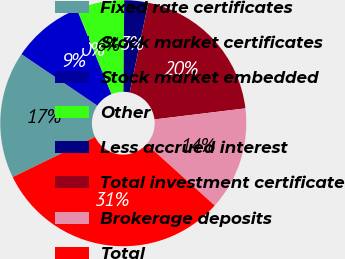Convert chart to OTSL. <chart><loc_0><loc_0><loc_500><loc_500><pie_chart><fcel>Fixed rate certificates<fcel>Stock market certificates<fcel>Stock market embedded<fcel>Other<fcel>Less accrued interest<fcel>Total investment certificate<fcel>Brokerage deposits<fcel>Total<nl><fcel>16.71%<fcel>9.35%<fcel>0.03%<fcel>6.25%<fcel>3.14%<fcel>19.82%<fcel>13.6%<fcel>31.11%<nl></chart> 